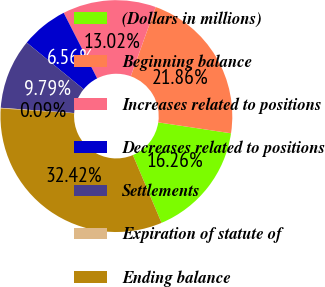Convert chart. <chart><loc_0><loc_0><loc_500><loc_500><pie_chart><fcel>(Dollars in millions)<fcel>Beginning balance<fcel>Increases related to positions<fcel>Decreases related to positions<fcel>Settlements<fcel>Expiration of statute of<fcel>Ending balance<nl><fcel>16.26%<fcel>21.86%<fcel>13.02%<fcel>6.56%<fcel>9.79%<fcel>0.09%<fcel>32.42%<nl></chart> 